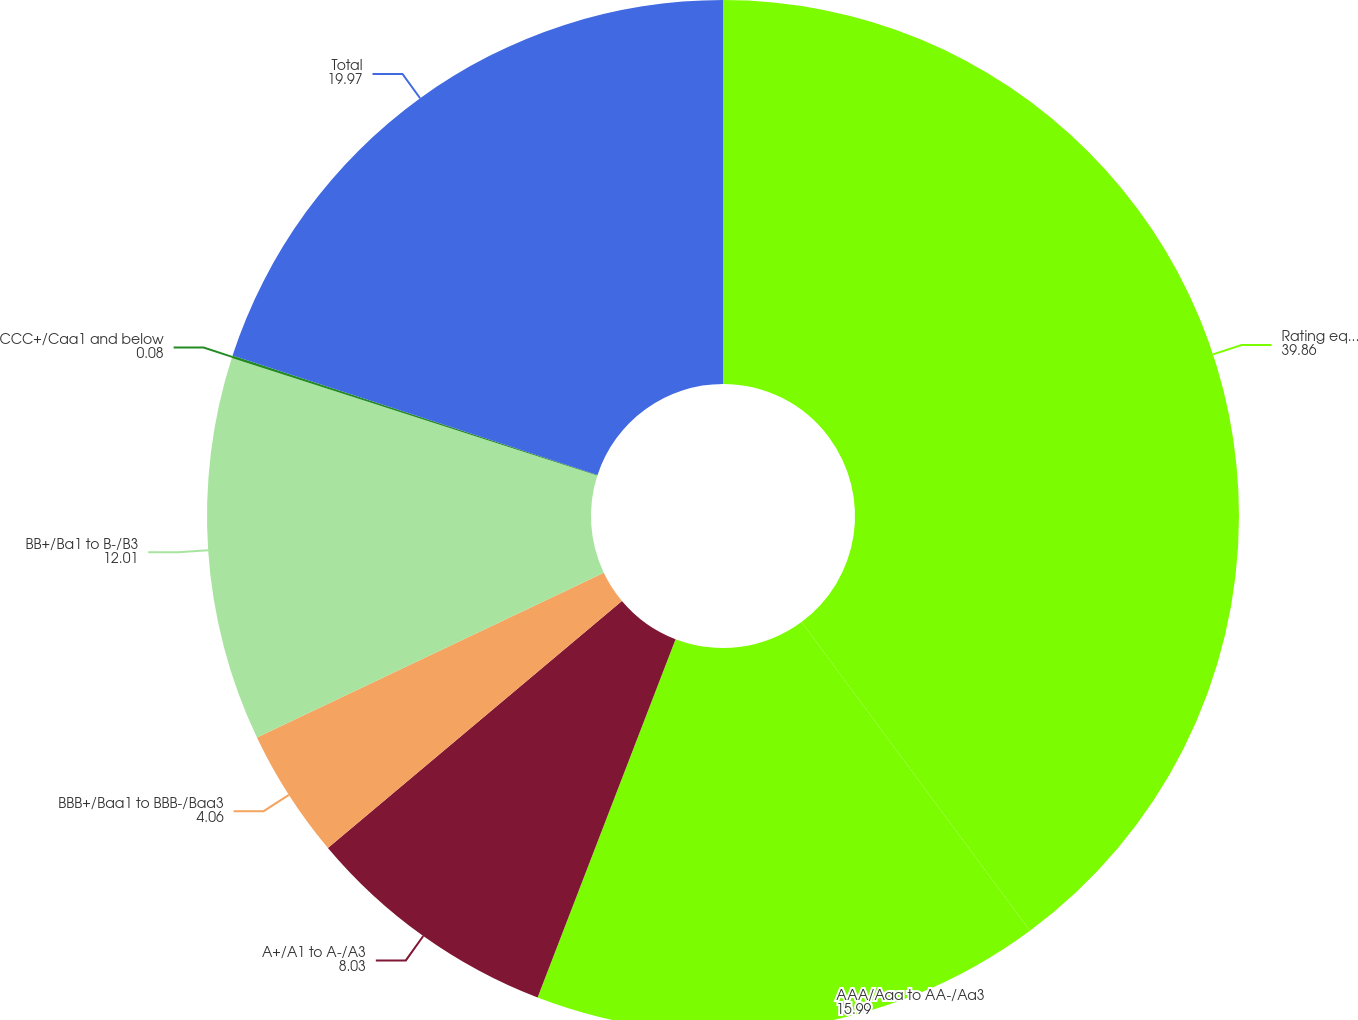Convert chart. <chart><loc_0><loc_0><loc_500><loc_500><pie_chart><fcel>Rating equivalent<fcel>AAA/Aaa to AA-/Aa3<fcel>A+/A1 to A-/A3<fcel>BBB+/Baa1 to BBB-/Baa3<fcel>BB+/Ba1 to B-/B3<fcel>CCC+/Caa1 and below<fcel>Total<nl><fcel>39.86%<fcel>15.99%<fcel>8.03%<fcel>4.06%<fcel>12.01%<fcel>0.08%<fcel>19.97%<nl></chart> 